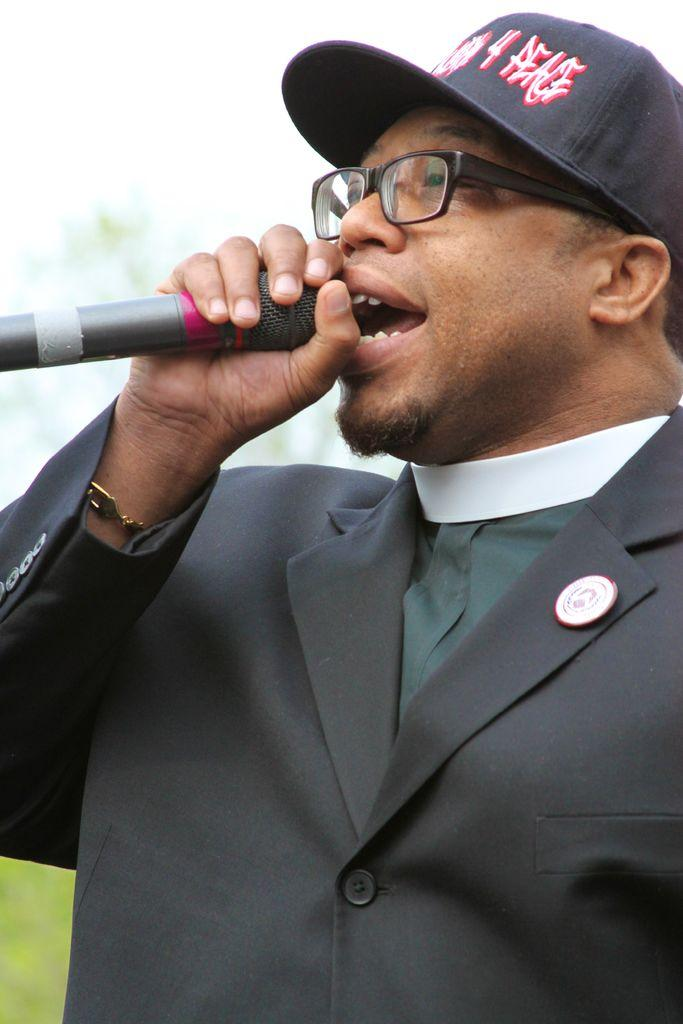What is the main subject of the image? The main subject of the image is a man. What is the man holding in the image? The man is holding a microphone. Can you describe the man's attire in the image? The man is wearing a cap and spectacles. How would you describe the background of the image? The background of the image is blurry. What type of mine can be seen in the background of the image? There is no mine present in the image; the background is blurry. How many needles are visible in the image? There are no needles present in the image. 